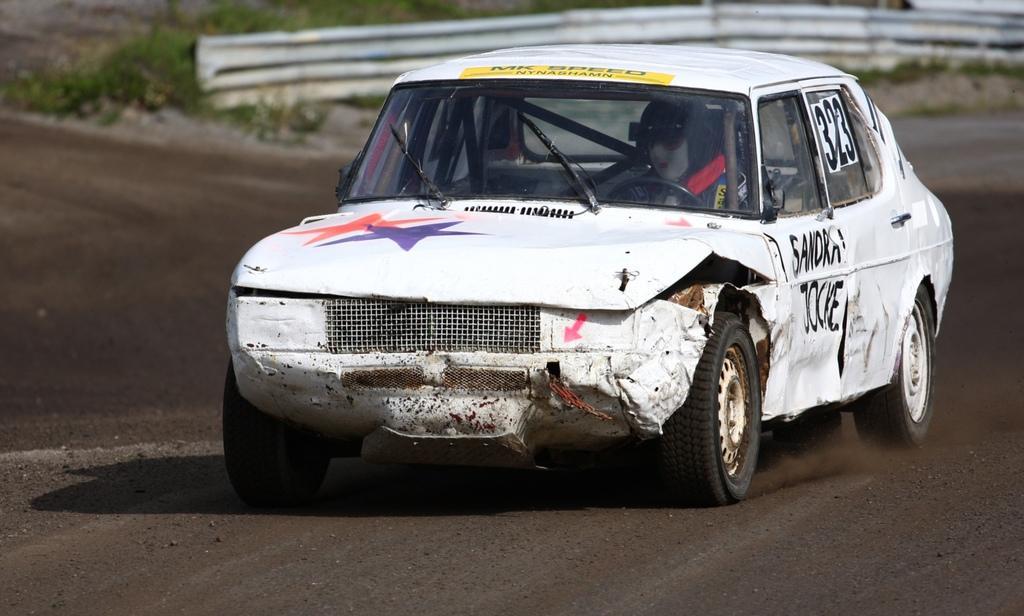How would you summarize this image in a sentence or two? There is a car in the center of the image, it seems like metal sheets and greenery in the background area. 